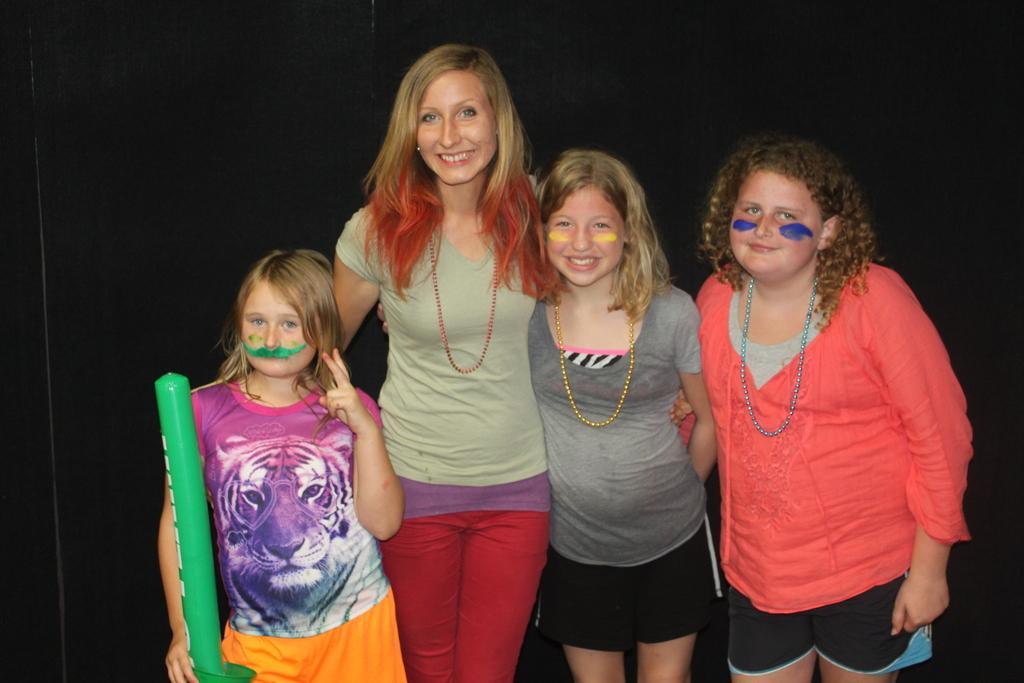Can you describe this image briefly? In this image there are four persons standing and smiling, and there is dark background. 